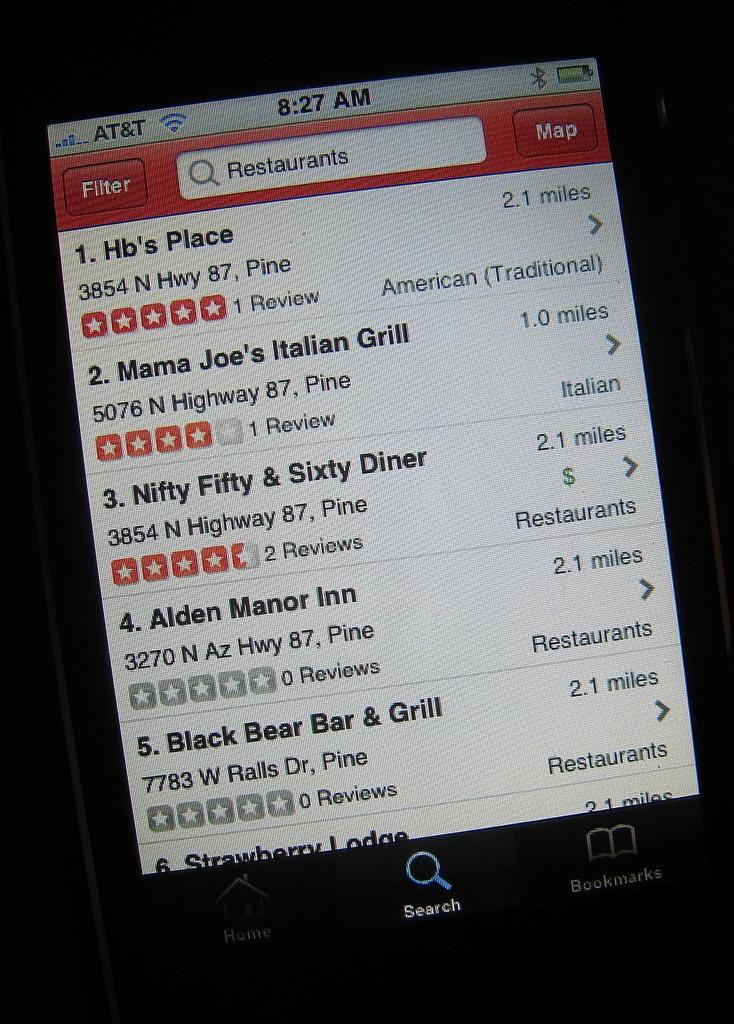What is the first restaurant on the list?
Keep it short and to the point. Hb's place. What is the address to alden manor inn?
Provide a short and direct response. 3270 n az hwy 87, pine. 